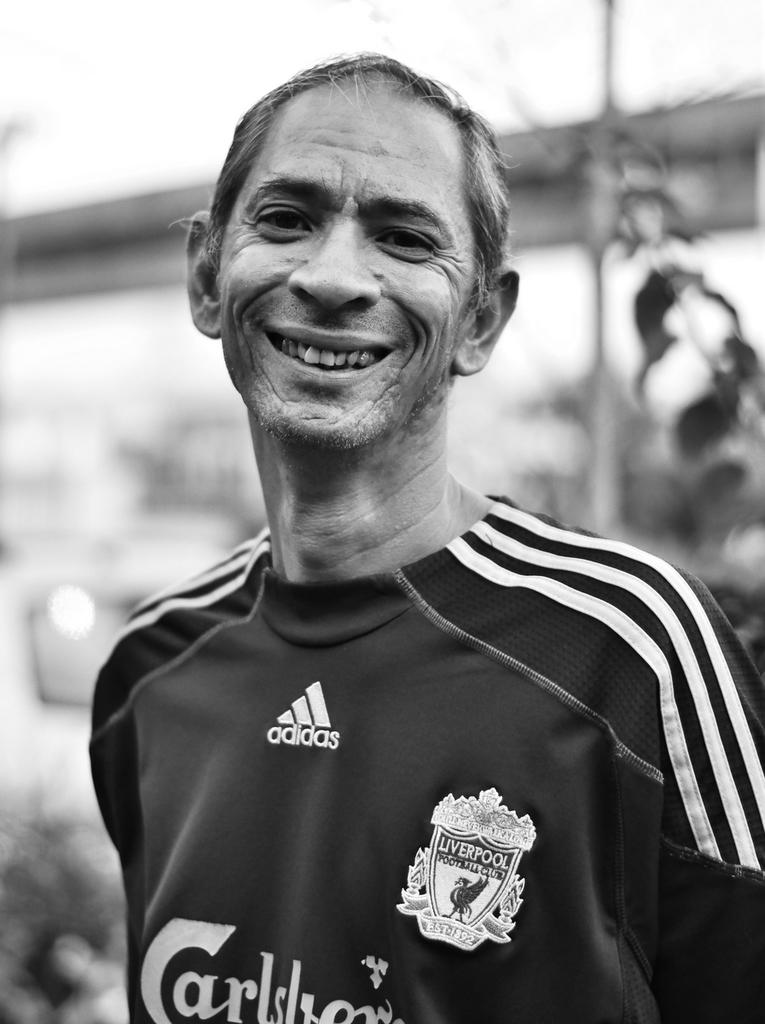What team jersey is he wearing?
Ensure brevity in your answer.  Liverpool. Is he sponsored by adidas?
Your answer should be very brief. Yes. 